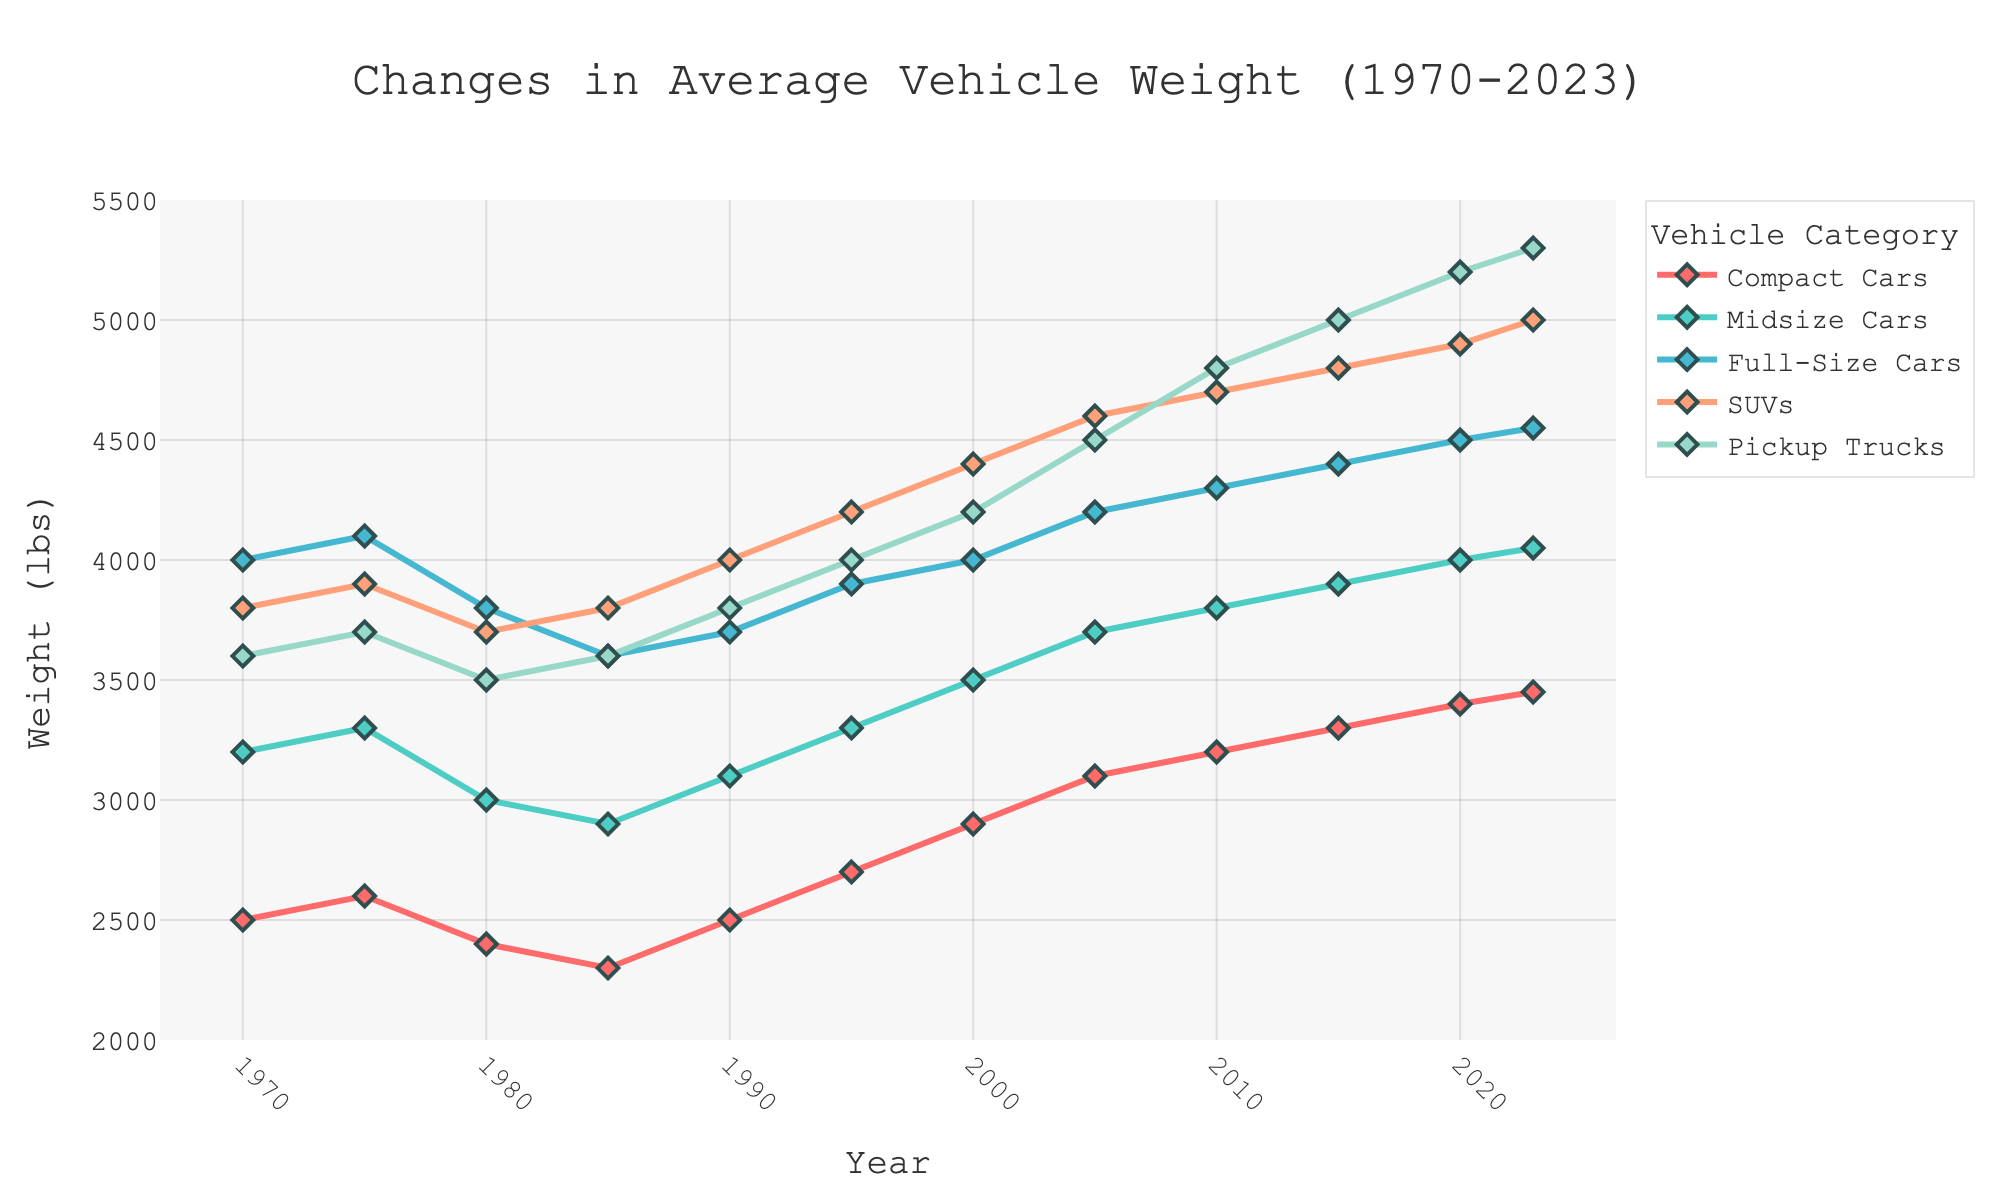What is the average weight of Compact Cars in 1980 and 2000? To calculate the average, we add the weight of Compact Cars in 1980 and 2000, then divide by 2. For 1980, it is 2400 lbs, and for 2000, it is 2900 lbs. So, (2400 + 2900) / 2 = 2650 lbs.
Answer: 2650 lbs Which vehicle category had the highest weight in 2023? By looking at the weight values for 2023, we see that Pickup Trucks have the highest weight at 5300 lbs.
Answer: Pickup Trucks How much did the weight of SUVs increase from 1970 to 2023? We subtract the weight of SUVs in 1970 from the weight in 2023. So, 5000 lbs (2023) - 3800 lbs (1970) = 1200 lbs.
Answer: 1200 lbs Between Full-Size Cars and Midsize Cars, which category showed a higher increase in weight from 1990 to 2023? Full-Size Cars increase: 4550 lbs (2023) - 3700 lbs (1990) = 850 lbs. Midsize Cars increase: 4050 lbs (2023) - 3100 lbs (1990) = 950 lbs. Therefore, Midsize Cars showed a higher increase in weight.
Answer: Midsize Cars What was the trend in the weight of Compact Cars from 1985 to 2023? From the graph, we see that the weight of Compact Cars increased consistently from 2300 lbs in 1985 to 3450 lbs in 2023.
Answer: Consistent Increase By how much did Pickup Trucks' weight change from 2005 to 2015? We subtract the weight of Pickup Trucks in 2005 from the weight in 2015. So, 5000 lbs (2015) - 4500 lbs (2005) = 500 lbs.
Answer: 500 lbs What is the average weight of Full-Size Cars and SUVs in 2010? First, we find the weights of Full-Size Cars and SUVs in 2010, which are 4300 lbs and 4700 lbs, respectively. The average weight is (4300 + 4700) / 2 = 4500 lbs.
Answer: 4500 lbs Compare the weight of Midsize Cars and Compact Cars in 1980. Which is heavier? The weight of Midsize Cars in 1980 is 3000 lbs, and the weight of Compact Cars is 2400 lbs. Therefore, Midsize Cars are heavier.
Answer: Midsize Cars Which category showed the highest weight increase between 1975 and 2023: Compact Cars, Midsize Cars, or SUVs? To find this, subtract the 1975 weight from the 2023 weight for each category: Compact Cars: 3450 - 2600 = 850 lbs, Midsize Cars: 4050 - 3300 = 750 lbs, SUVs: 5000 - 3900 = 1100 lbs. SUVs showed the highest increase.
Answer: SUVs 